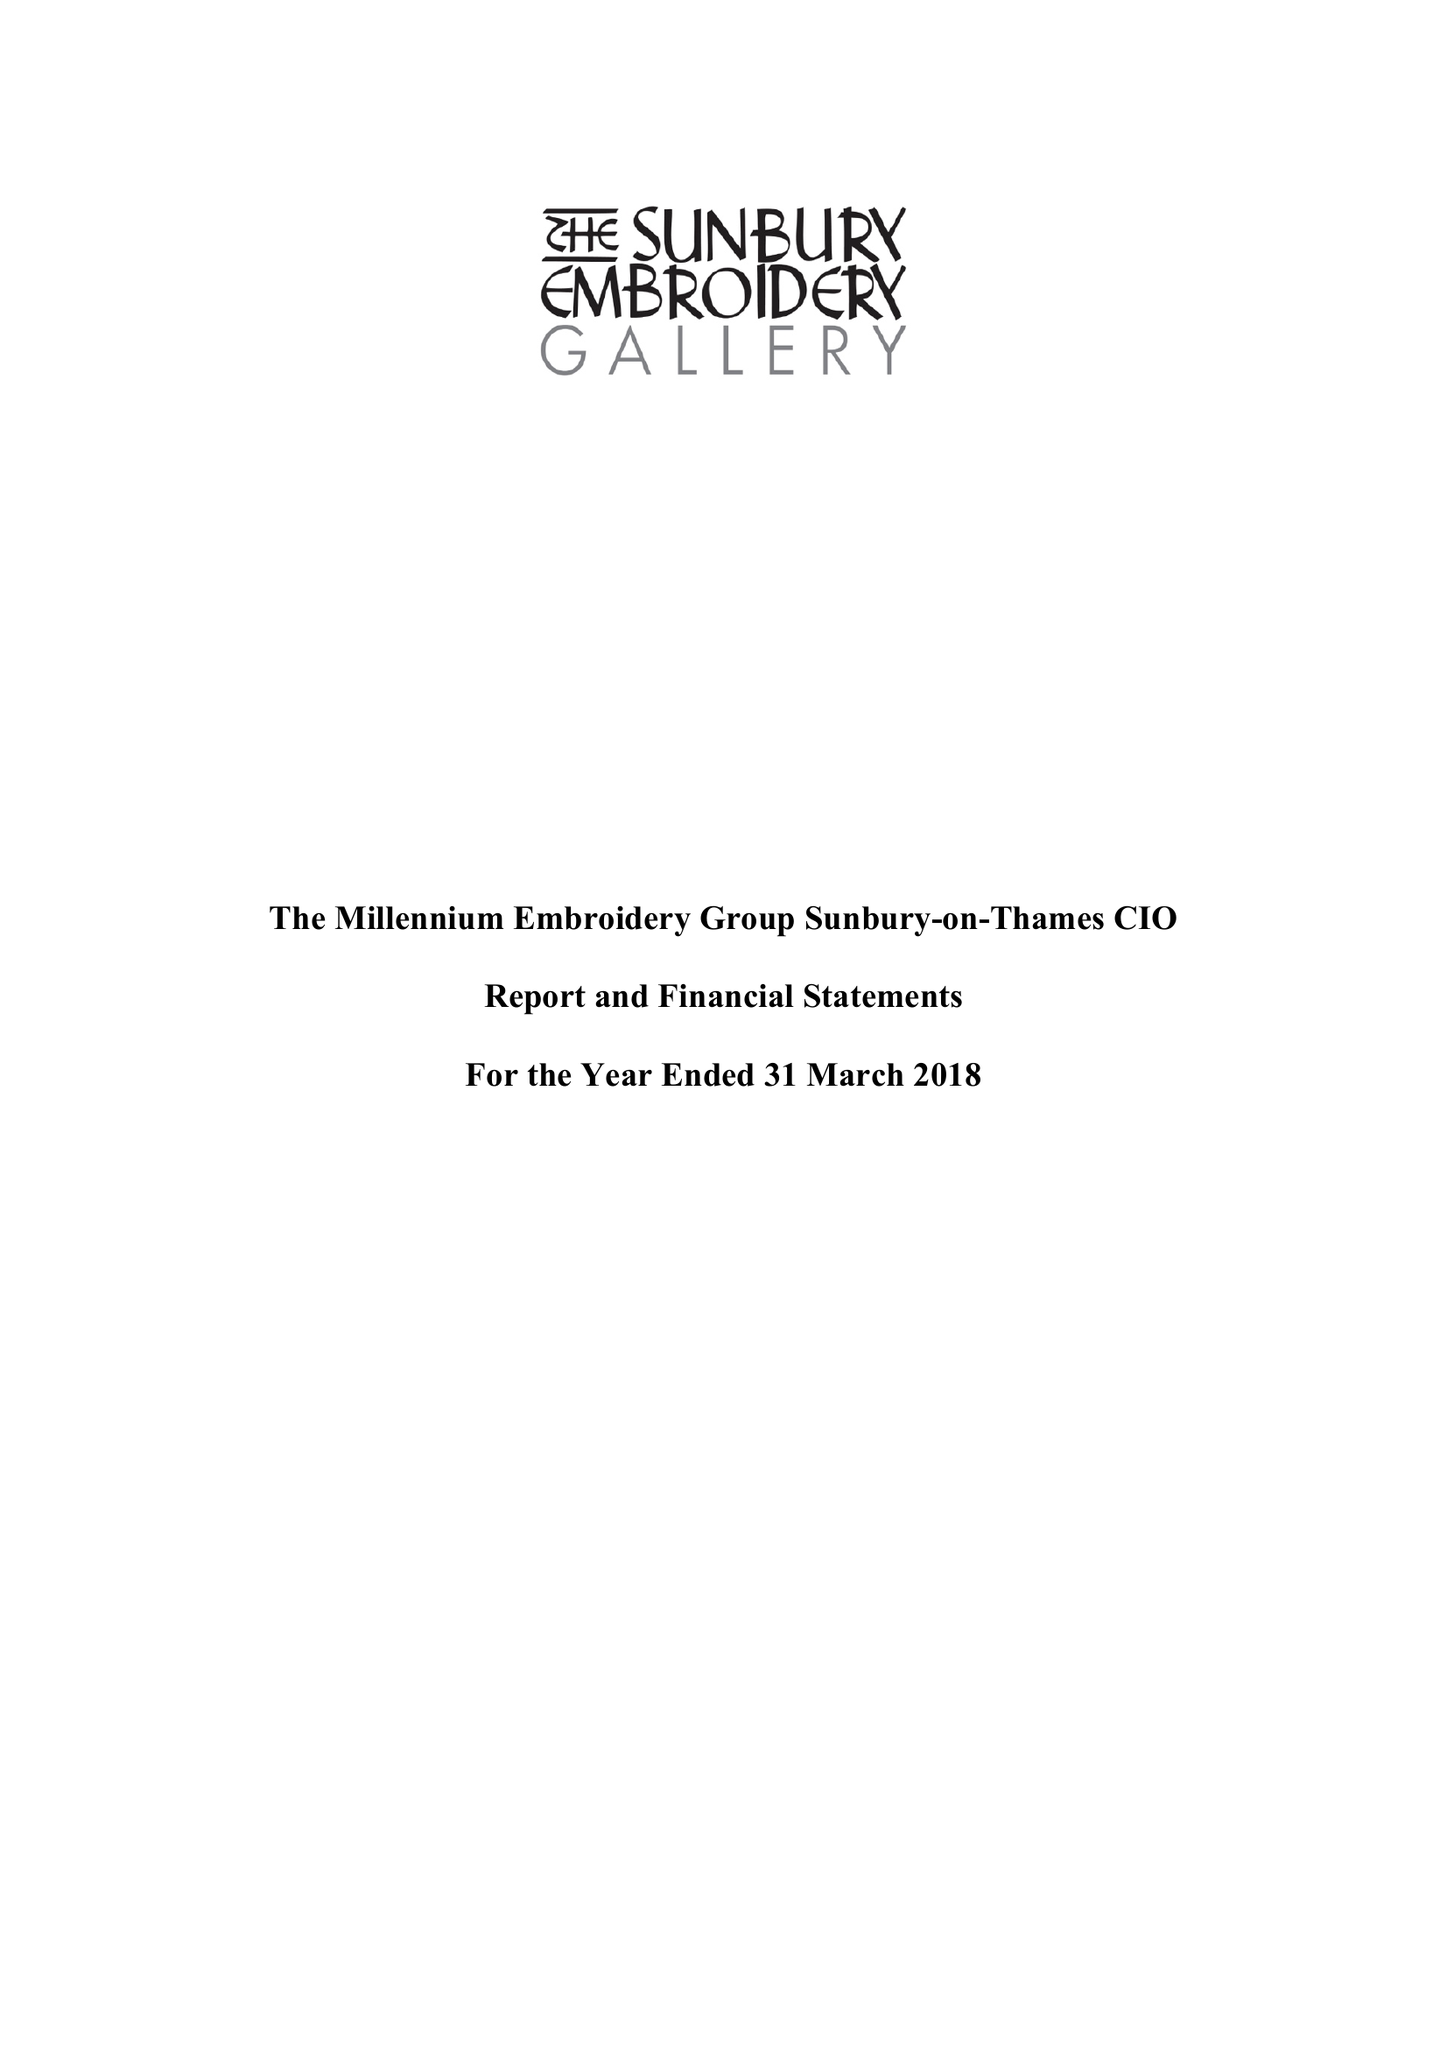What is the value for the address__post_town?
Answer the question using a single word or phrase. SUNBURY-ON-THAMES 